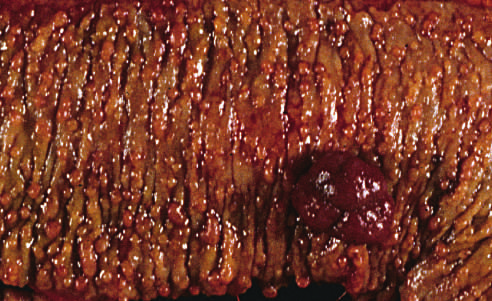re hundreds of small colonic polyps present along with a dominant polyp (right)?
Answer the question using a single word or phrase. Yes 